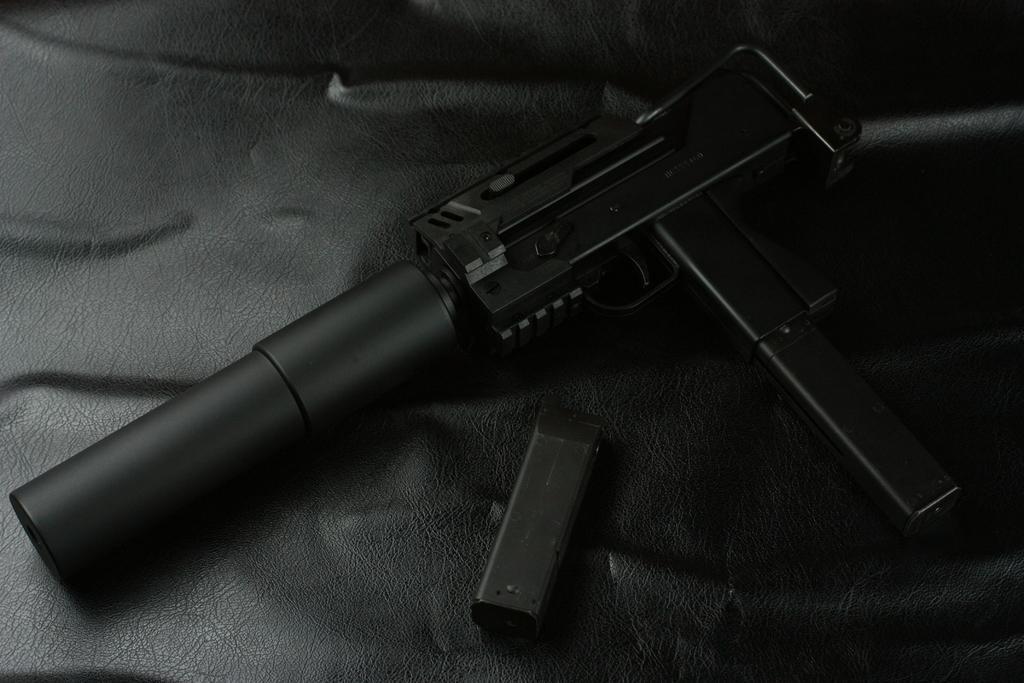How would you summarize this image in a sentence or two? This is a black and white picture, there is a gun and magazine on a leather floor. 